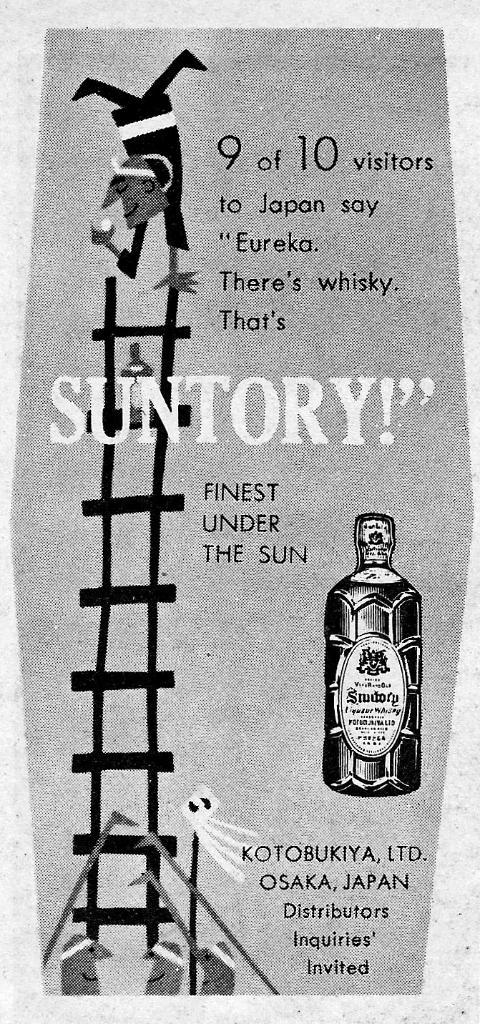<image>
Share a concise interpretation of the image provided. 9 out of 10 visitors to Japan say "Eureka. There's whisky. That's SUNTORY!" 